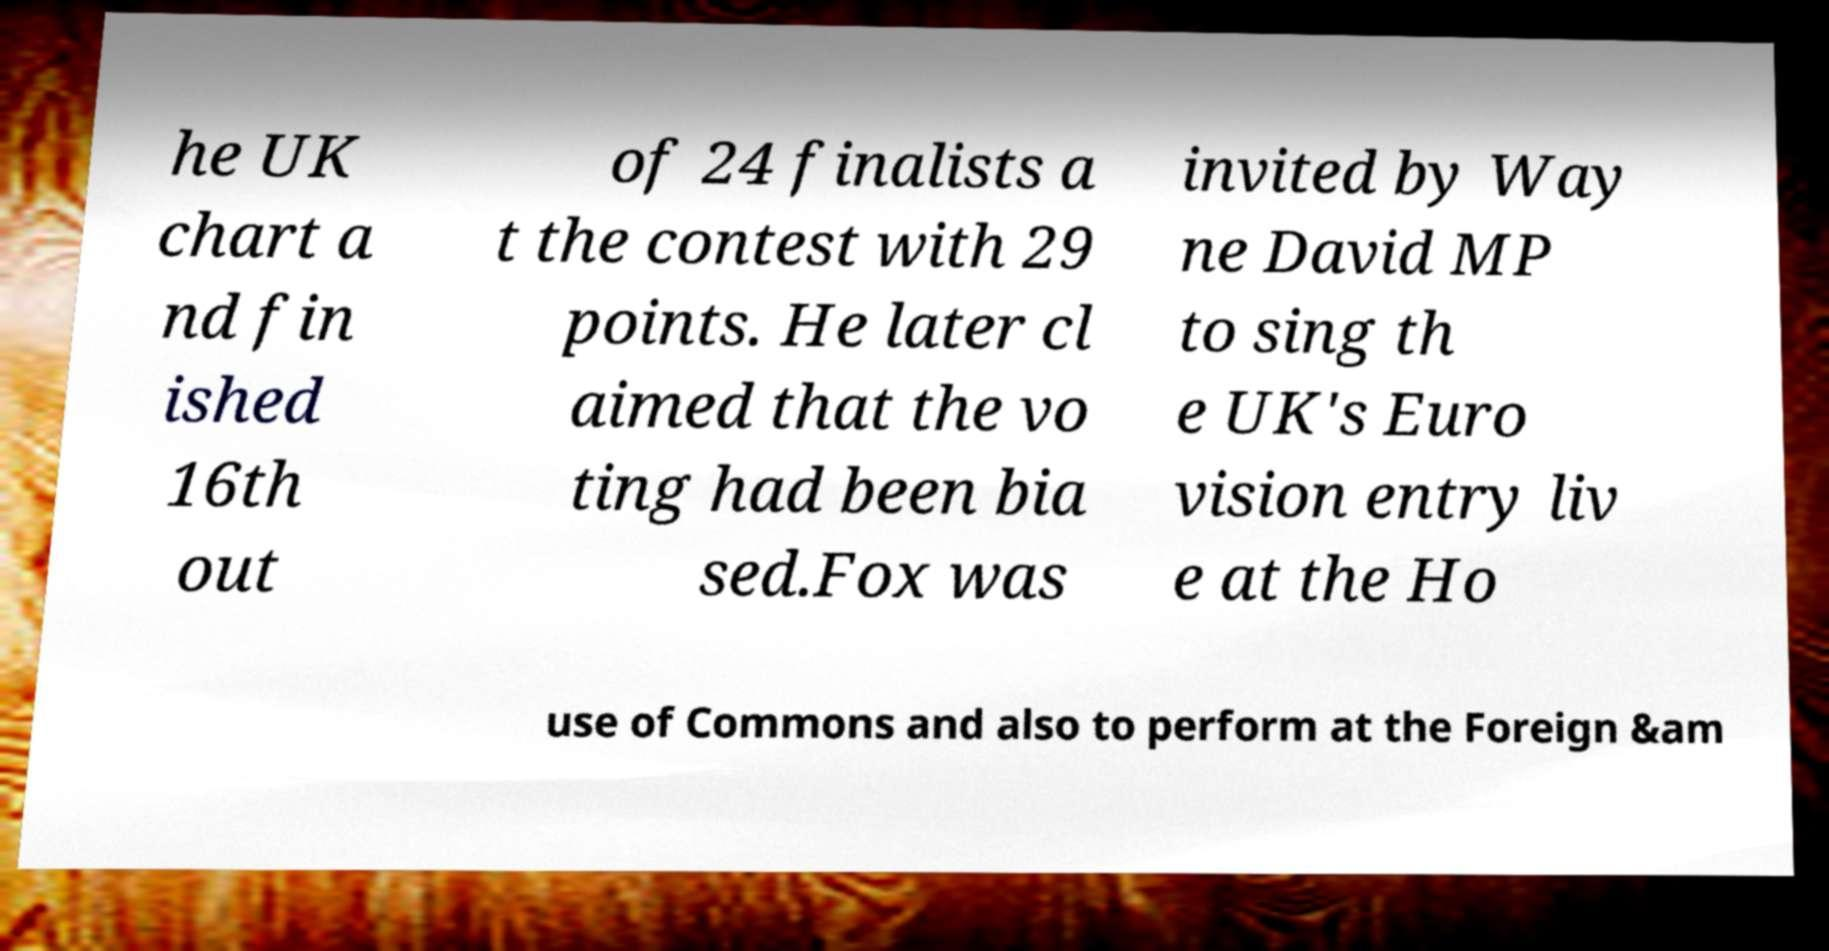What messages or text are displayed in this image? I need them in a readable, typed format. he UK chart a nd fin ished 16th out of 24 finalists a t the contest with 29 points. He later cl aimed that the vo ting had been bia sed.Fox was invited by Way ne David MP to sing th e UK's Euro vision entry liv e at the Ho use of Commons and also to perform at the Foreign &am 